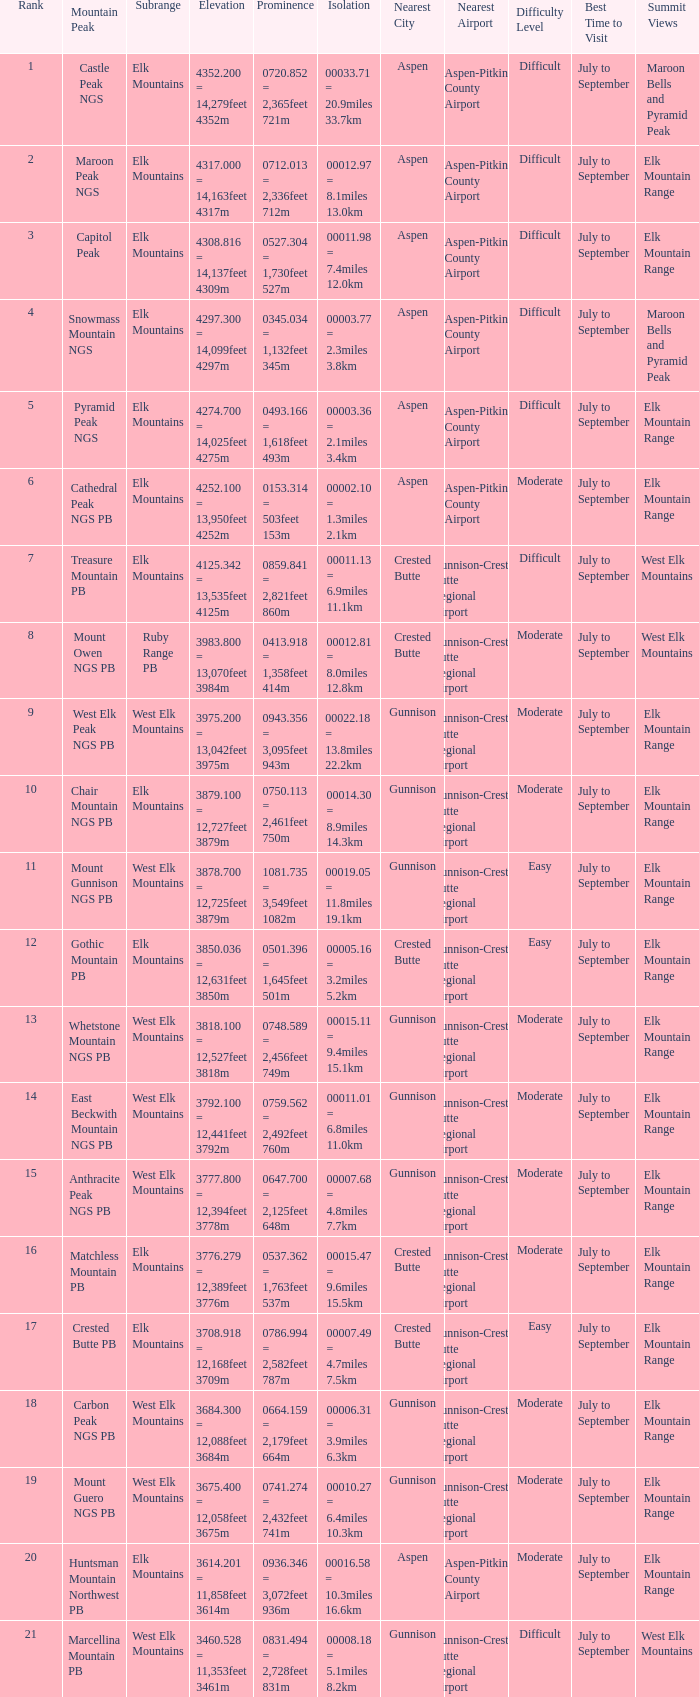Name the Prominence of the Mountain Peak of matchless mountain pb? 0537.362 = 1,763feet 537m. 